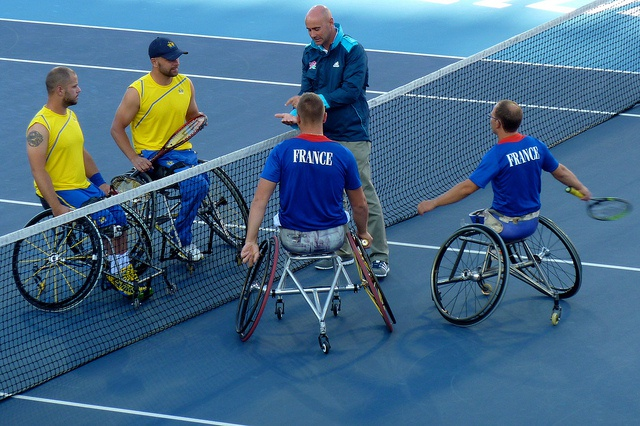Describe the objects in this image and their specific colors. I can see people in lightblue, navy, darkblue, gray, and black tones, people in lightblue, gold, olive, navy, and black tones, people in lightblue, gray, gold, and olive tones, people in lightblue, navy, black, gray, and blue tones, and people in lightblue, navy, blue, darkblue, and gray tones in this image. 